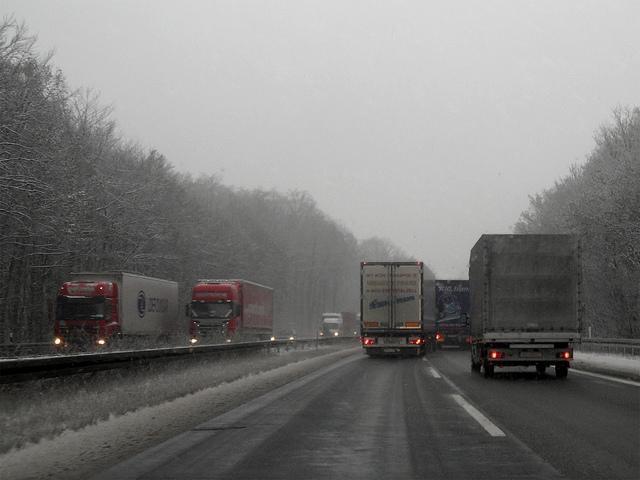What is blowing in the wind?
From the following set of four choices, select the accurate answer to respond to the question.
Options: Sand, leaves, rain, snow. Snow. 